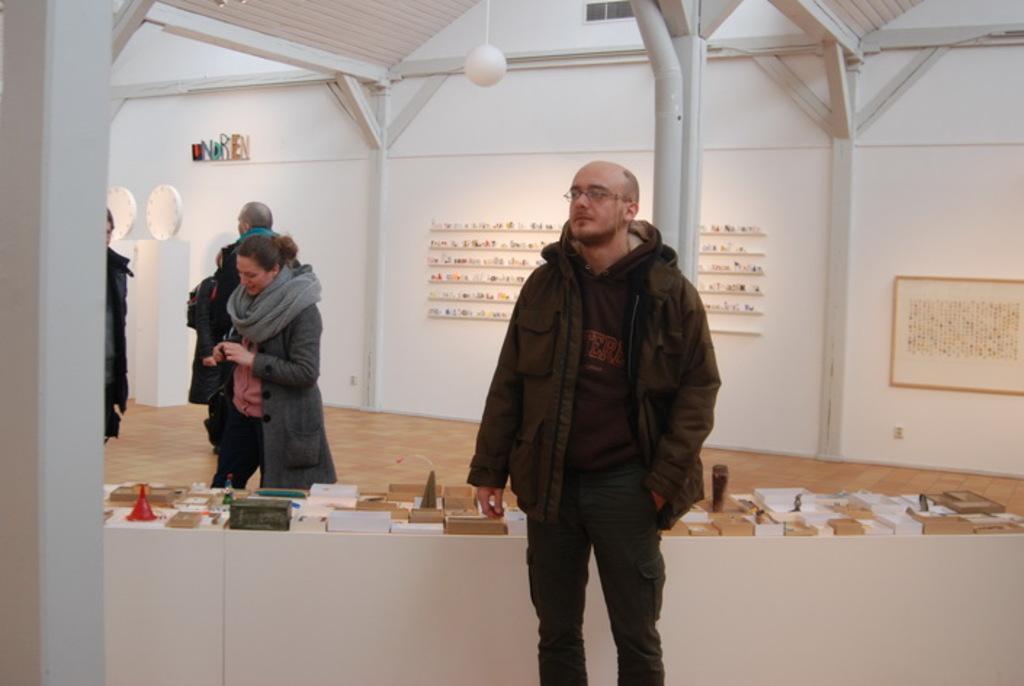Describe this image in one or two sentences. In this image, there are a few people. We can see the ground. We can also see some objects on the table. We can see the wall with a poster and some objects. We can also see some text written. We can see some white colored objects on the pillars. We can also see the roof and an object. 